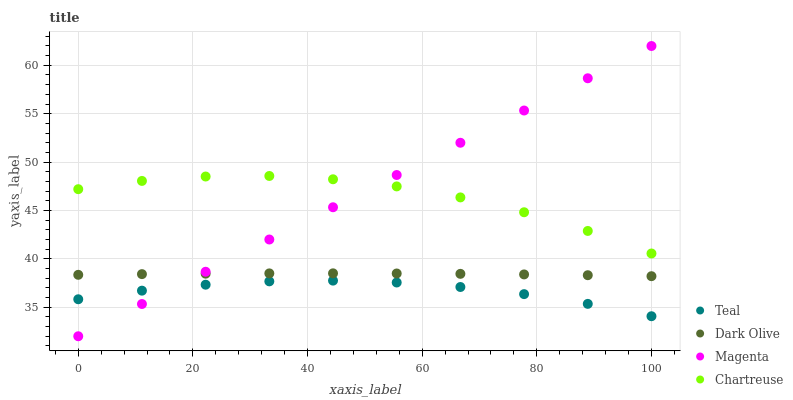Does Teal have the minimum area under the curve?
Answer yes or no. Yes. Does Magenta have the maximum area under the curve?
Answer yes or no. Yes. Does Dark Olive have the minimum area under the curve?
Answer yes or no. No. Does Dark Olive have the maximum area under the curve?
Answer yes or no. No. Is Magenta the smoothest?
Answer yes or no. Yes. Is Chartreuse the roughest?
Answer yes or no. Yes. Is Dark Olive the smoothest?
Answer yes or no. No. Is Dark Olive the roughest?
Answer yes or no. No. Does Magenta have the lowest value?
Answer yes or no. Yes. Does Dark Olive have the lowest value?
Answer yes or no. No. Does Magenta have the highest value?
Answer yes or no. Yes. Does Dark Olive have the highest value?
Answer yes or no. No. Is Dark Olive less than Chartreuse?
Answer yes or no. Yes. Is Chartreuse greater than Teal?
Answer yes or no. Yes. Does Chartreuse intersect Magenta?
Answer yes or no. Yes. Is Chartreuse less than Magenta?
Answer yes or no. No. Is Chartreuse greater than Magenta?
Answer yes or no. No. Does Dark Olive intersect Chartreuse?
Answer yes or no. No. 